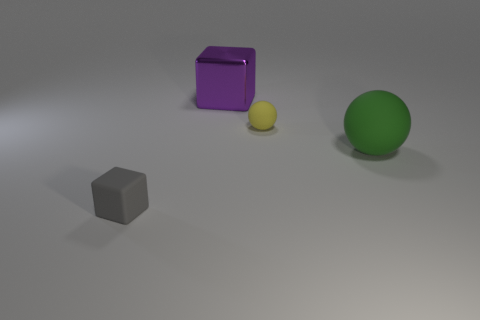Add 3 big matte spheres. How many objects exist? 7 Add 4 large green matte balls. How many large green matte balls are left? 5 Add 1 big metallic cubes. How many big metallic cubes exist? 2 Subtract 0 gray balls. How many objects are left? 4 Subtract all tiny yellow rubber cylinders. Subtract all purple cubes. How many objects are left? 3 